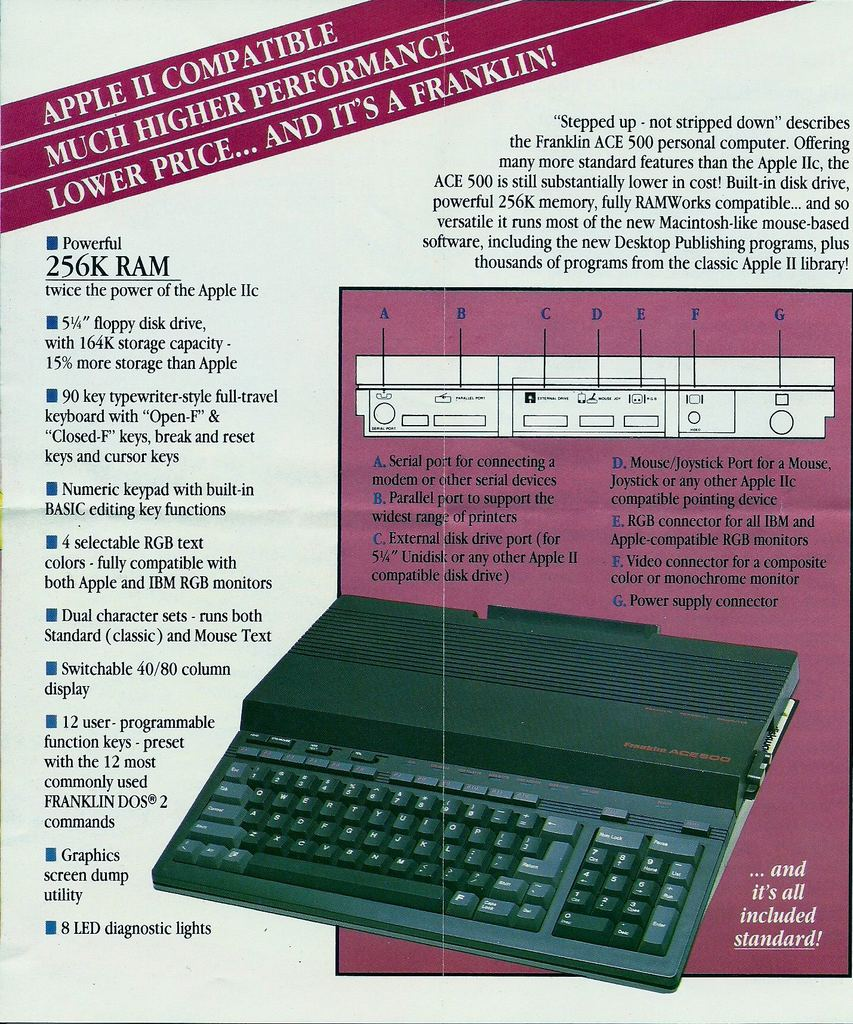Can you list the main features of the computer in the image? Certainly! The computer, Franklin ACE 500, showcases features such as 256K RAM, a 5.25" floppy disk drive, a full-travel keyboard with separate numeric keypad, basic editing functions, RGB text colors compatibility, dual character sets, switchable 40/80 column text, 12 programmable function keys, a graphics utility, 8 LED diagnostic lights, and various ports for connectivity, all included as standard. 